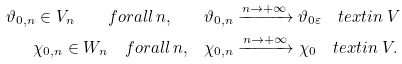Convert formula to latex. <formula><loc_0><loc_0><loc_500><loc_500>\vartheta _ { 0 , n } \in V _ { n } \quad f o r a l l \, n , \quad & \vartheta _ { 0 , n } \xrightarrow { n \rightarrow + \infty } \vartheta _ { 0 \varepsilon } \quad t e x t { i n } \ V \\ \chi _ { 0 , n } \in W _ { n } \quad f o r a l l \, n , \quad & \chi _ { 0 , n } \xrightarrow { n \rightarrow + \infty } \chi _ { 0 } \quad t e x t { i n } \ V .</formula> 